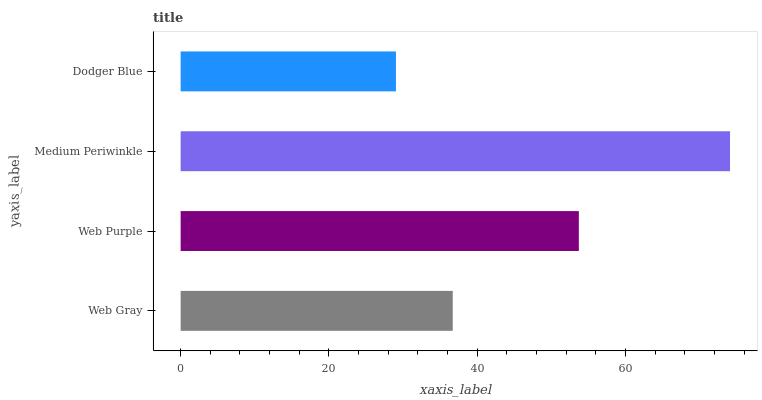Is Dodger Blue the minimum?
Answer yes or no. Yes. Is Medium Periwinkle the maximum?
Answer yes or no. Yes. Is Web Purple the minimum?
Answer yes or no. No. Is Web Purple the maximum?
Answer yes or no. No. Is Web Purple greater than Web Gray?
Answer yes or no. Yes. Is Web Gray less than Web Purple?
Answer yes or no. Yes. Is Web Gray greater than Web Purple?
Answer yes or no. No. Is Web Purple less than Web Gray?
Answer yes or no. No. Is Web Purple the high median?
Answer yes or no. Yes. Is Web Gray the low median?
Answer yes or no. Yes. Is Web Gray the high median?
Answer yes or no. No. Is Web Purple the low median?
Answer yes or no. No. 